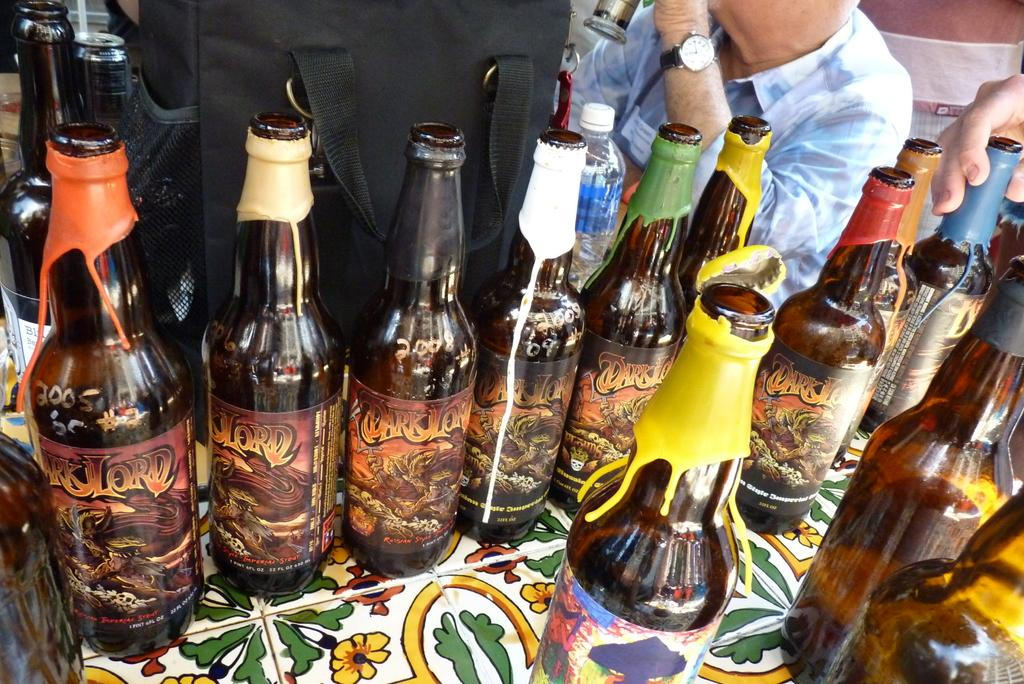<image>
Provide a brief description of the given image. Bottles of Dark Lord imperial stout ale are covered with wax. 